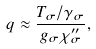<formula> <loc_0><loc_0><loc_500><loc_500>q \approx \frac { T _ { \sigma } / \gamma _ { \sigma } } { g _ { \sigma } \chi ^ { \prime \prime } _ { \sigma } } ,</formula> 